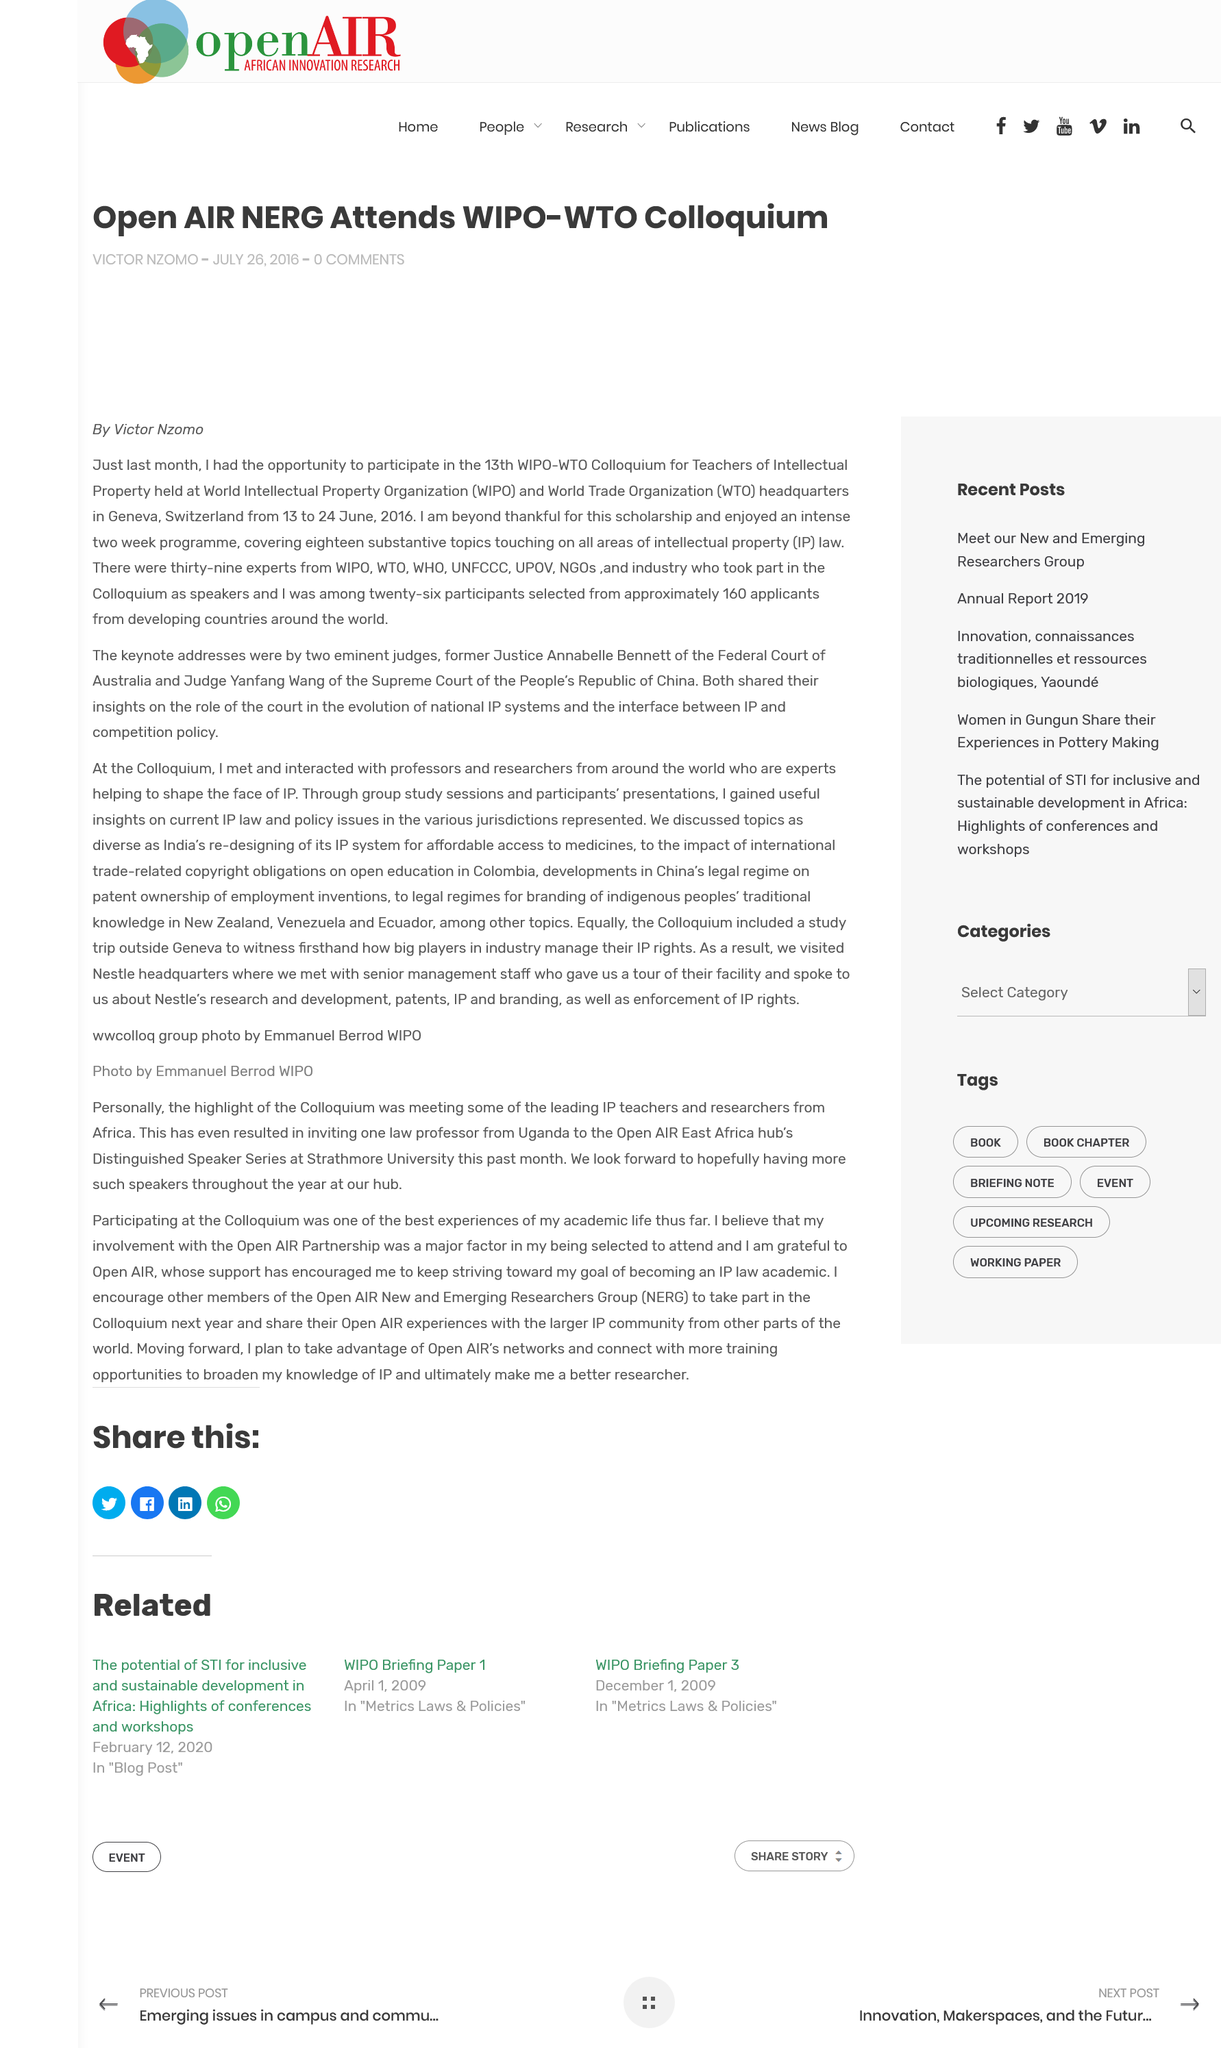Point out several critical features in this image. The 13th WIPO-WTO Colloquium for Teachers of Intellectual Property was held from June 13 to June 24, 2016. Eighteen substantive topics were covered in the intense two-week program of the 13th WIPO-WTO Colloquium for Teachers of Intellectual Property. The 13th WIPO-WTO Colloquium for Teachers of Intellectual Property was held in June 2016 at WIPO and WTO headquarters in Geneva, Switzerland, which was located in Switzerland. 